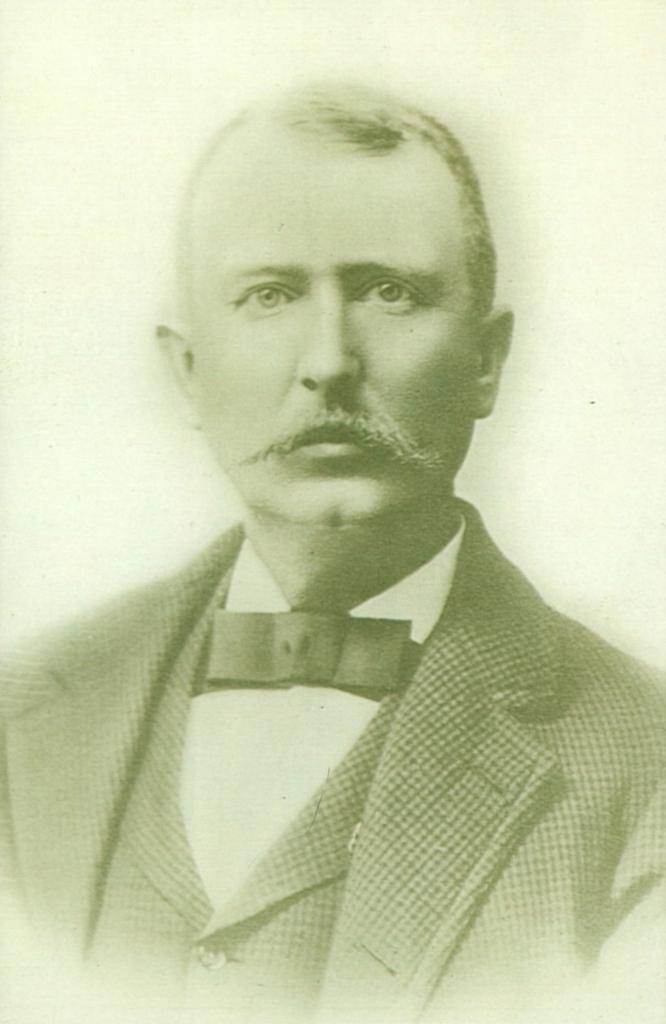Could you give a brief overview of what you see in this image? This image is a photograph of a man. He is wearing a suit. 